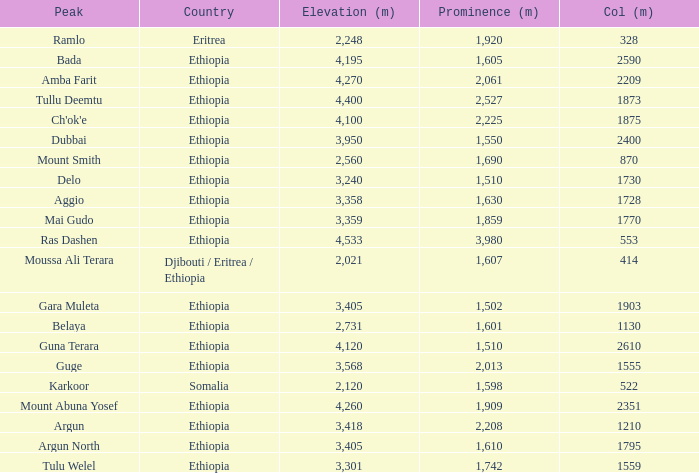What is the total prominence number in m of ethiopia, which has a col in m of 1728 and an elevation less than 3,358? 0.0. 